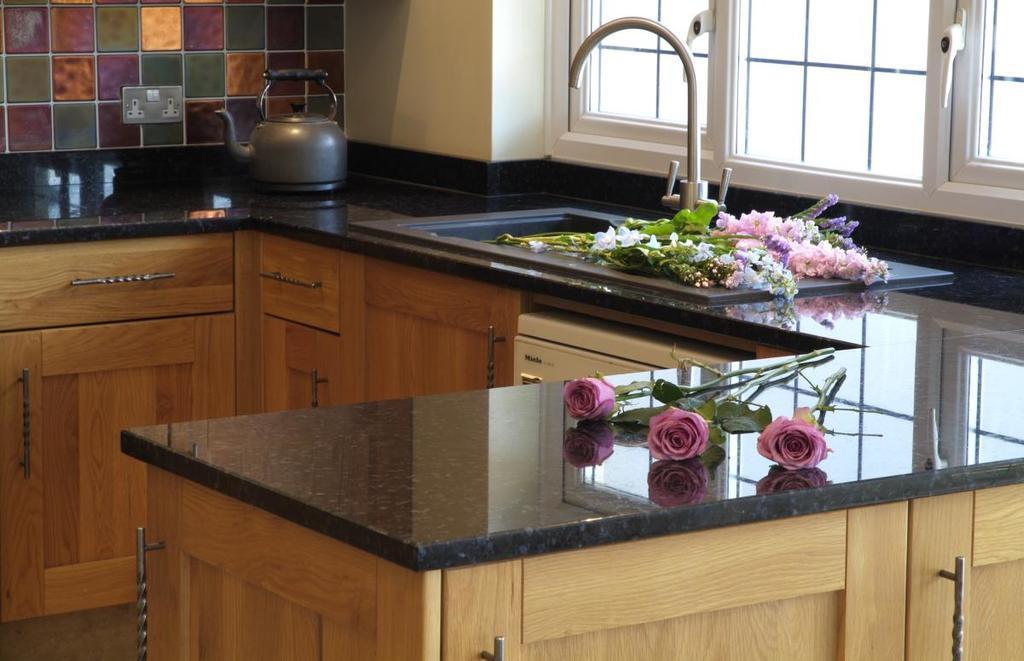How would you summarize this image in a sentence or two? There is a table with drawers. On the table there are roses, kettle and a wash basin with tap. Near the wash basin there are many flowers. In the back there is a wall with socket. Also there are windows. 